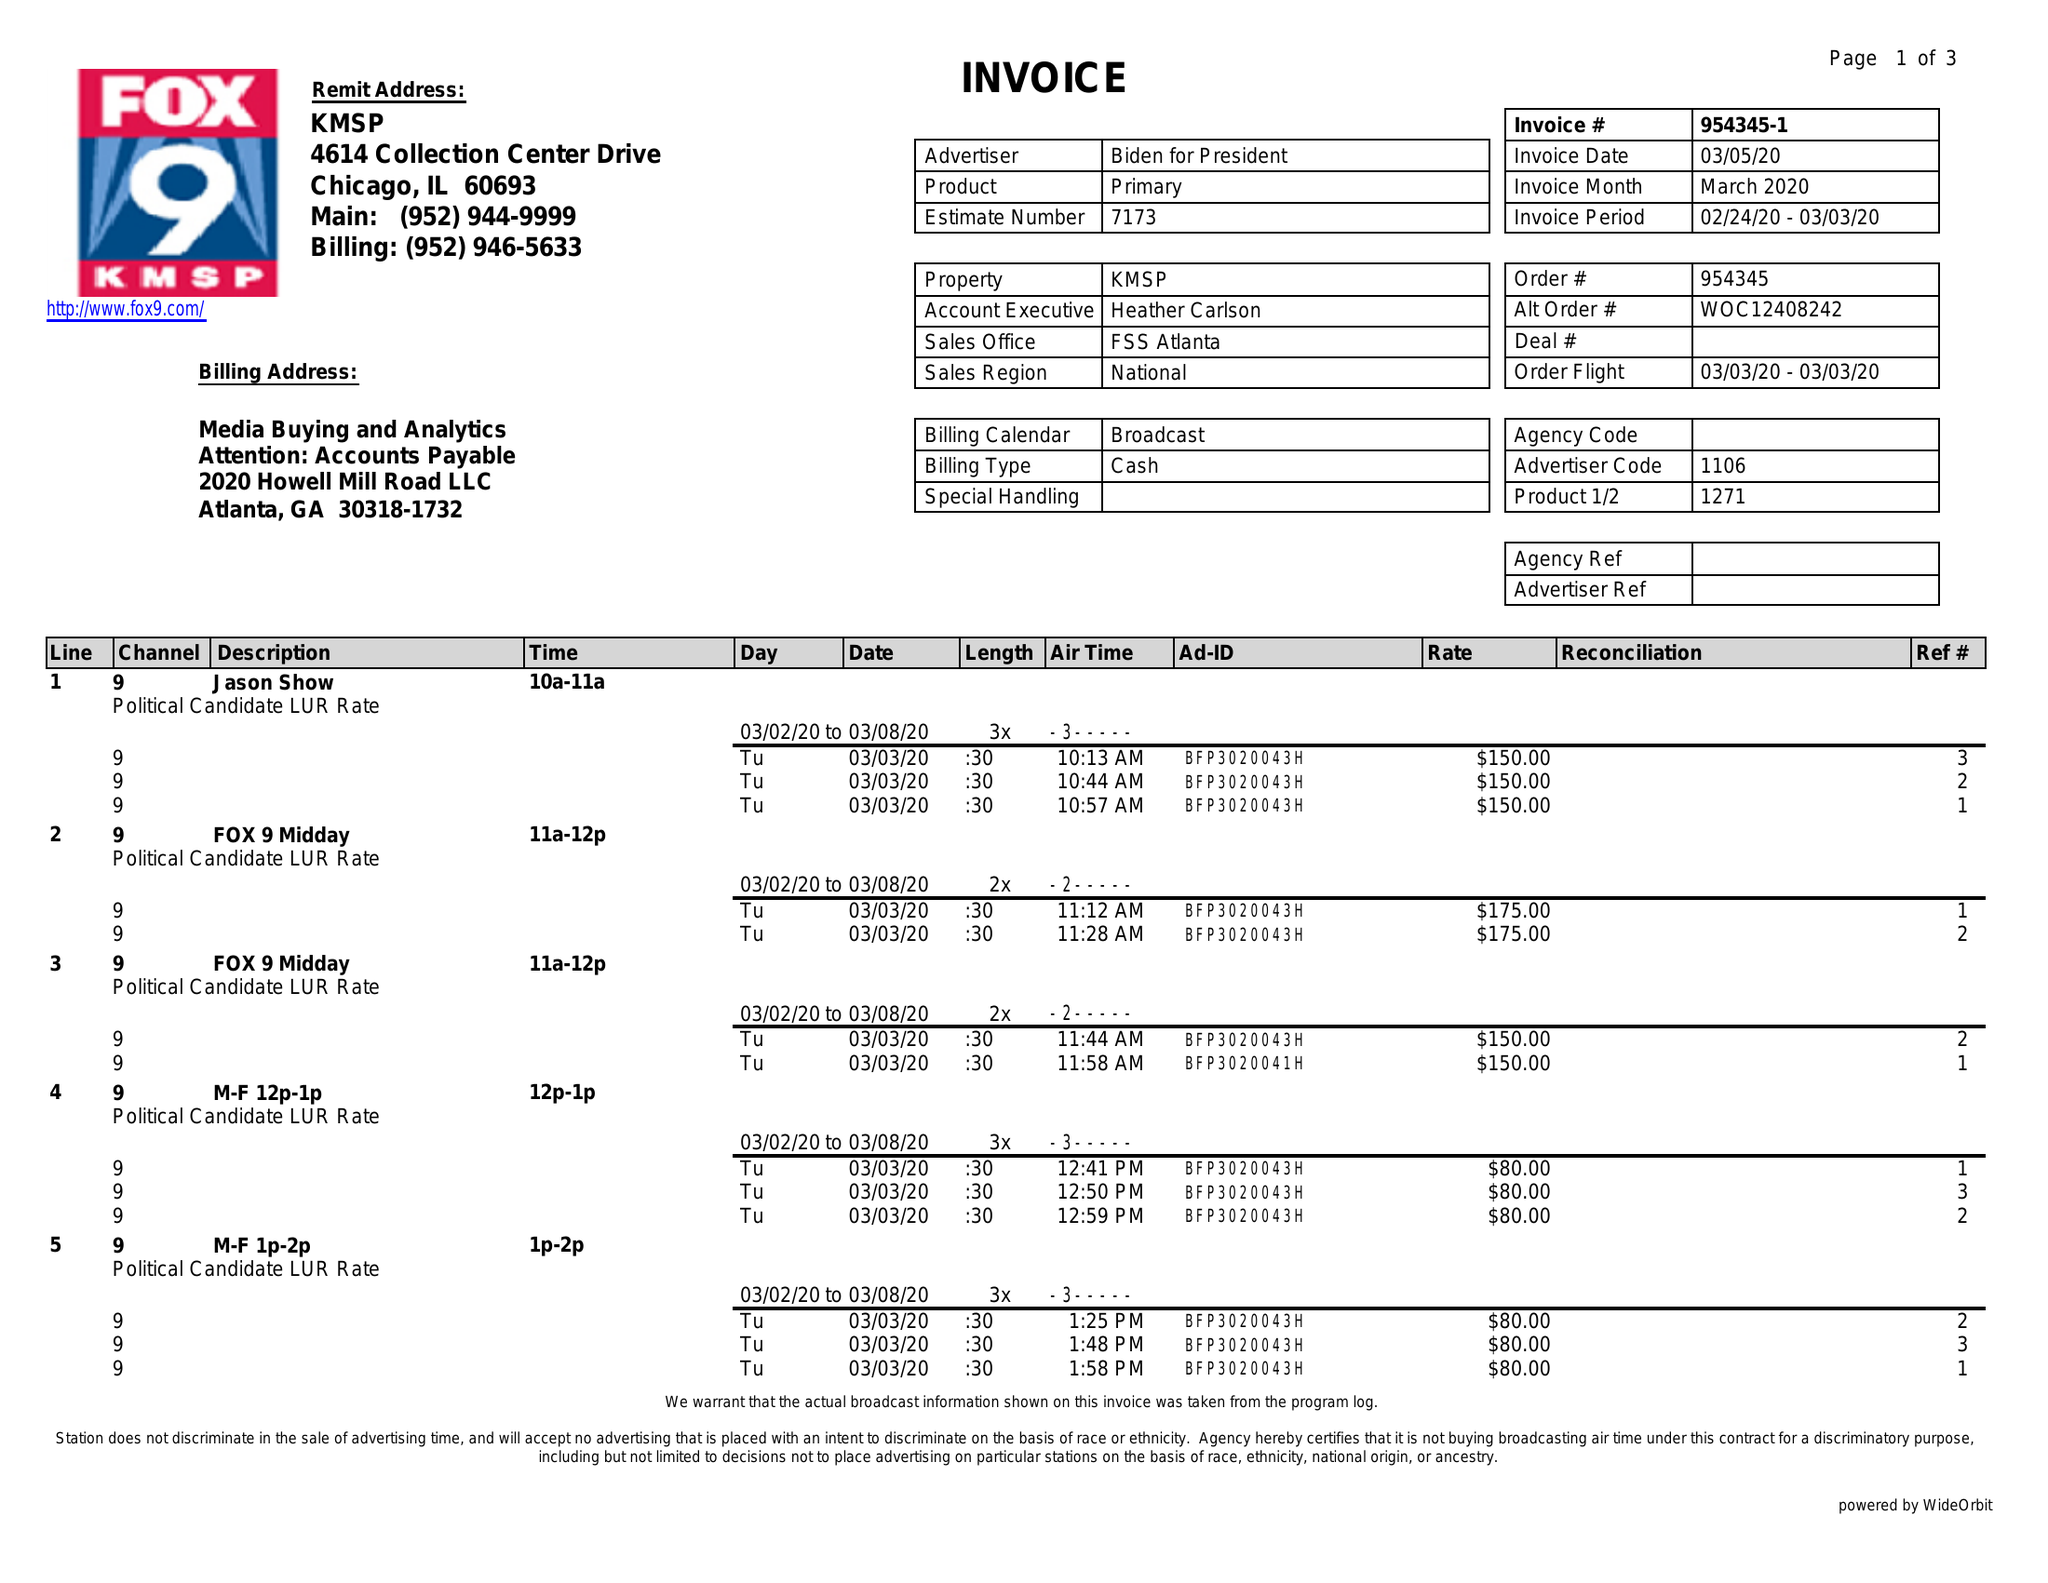What is the value for the gross_amount?
Answer the question using a single word or phrase. 5470.00 